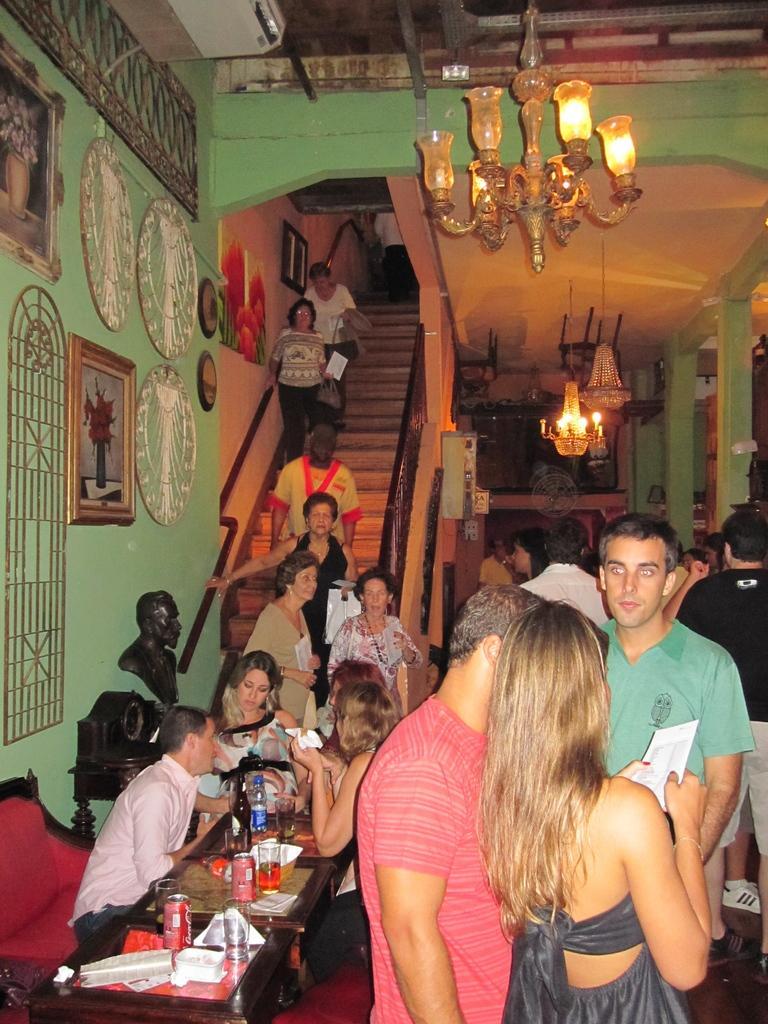How would you summarize this image in a sentence or two? There are group of people in this room and few are coming down by stairs. There is chandelier hanging over here. On the wall there are frames. 